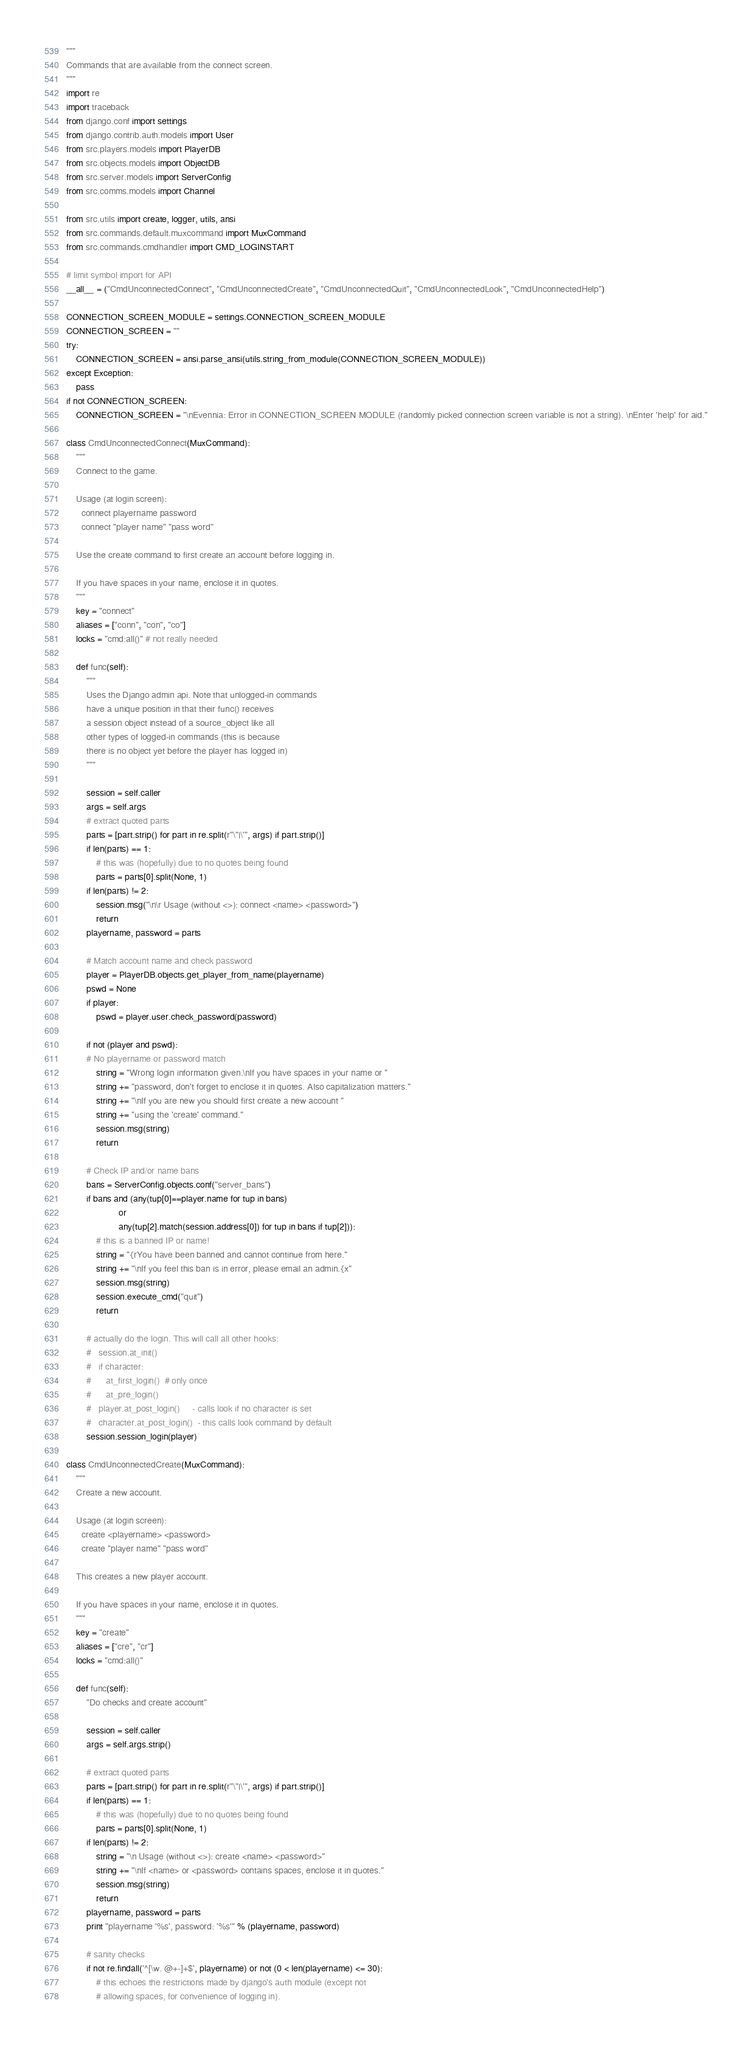Convert code to text. <code><loc_0><loc_0><loc_500><loc_500><_Python_>"""
Commands that are available from the connect screen.
"""
import re
import traceback
from django.conf import settings
from django.contrib.auth.models import User
from src.players.models import PlayerDB
from src.objects.models import ObjectDB
from src.server.models import ServerConfig
from src.comms.models import Channel

from src.utils import create, logger, utils, ansi
from src.commands.default.muxcommand import MuxCommand
from src.commands.cmdhandler import CMD_LOGINSTART

# limit symbol import for API
__all__ = ("CmdUnconnectedConnect", "CmdUnconnectedCreate", "CmdUnconnectedQuit", "CmdUnconnectedLook", "CmdUnconnectedHelp")

CONNECTION_SCREEN_MODULE = settings.CONNECTION_SCREEN_MODULE
CONNECTION_SCREEN = ""
try:
    CONNECTION_SCREEN = ansi.parse_ansi(utils.string_from_module(CONNECTION_SCREEN_MODULE))
except Exception:
    pass
if not CONNECTION_SCREEN:
    CONNECTION_SCREEN = "\nEvennia: Error in CONNECTION_SCREEN MODULE (randomly picked connection screen variable is not a string). \nEnter 'help' for aid."

class CmdUnconnectedConnect(MuxCommand):
    """
    Connect to the game.

    Usage (at login screen):
      connect playername password
      connect "player name" "pass word"

    Use the create command to first create an account before logging in.

    If you have spaces in your name, enclose it in quotes.
    """
    key = "connect"
    aliases = ["conn", "con", "co"]
    locks = "cmd:all()" # not really needed

    def func(self):
        """
        Uses the Django admin api. Note that unlogged-in commands
        have a unique position in that their func() receives
        a session object instead of a source_object like all
        other types of logged-in commands (this is because
        there is no object yet before the player has logged in)
        """

        session = self.caller
        args = self.args
        # extract quoted parts
        parts = [part.strip() for part in re.split(r"\"|\'", args) if part.strip()]
        if len(parts) == 1:
            # this was (hopefully) due to no quotes being found
            parts = parts[0].split(None, 1)
        if len(parts) != 2:
            session.msg("\n\r Usage (without <>): connect <name> <password>")
            return
        playername, password = parts

        # Match account name and check password
        player = PlayerDB.objects.get_player_from_name(playername)
        pswd = None
        if player:
            pswd = player.user.check_password(password)

        if not (player and pswd):
        # No playername or password match
            string = "Wrong login information given.\nIf you have spaces in your name or "
            string += "password, don't forget to enclose it in quotes. Also capitalization matters."
            string += "\nIf you are new you should first create a new account "
            string += "using the 'create' command."
            session.msg(string)
            return

        # Check IP and/or name bans
        bans = ServerConfig.objects.conf("server_bans")
        if bans and (any(tup[0]==player.name for tup in bans)
                     or
                     any(tup[2].match(session.address[0]) for tup in bans if tup[2])):
            # this is a banned IP or name!
            string = "{rYou have been banned and cannot continue from here."
            string += "\nIf you feel this ban is in error, please email an admin.{x"
            session.msg(string)
            session.execute_cmd("quit")
            return

        # actually do the login. This will call all other hooks:
        #   session.at_init()
        #   if character:
        #      at_first_login()  # only once
        #      at_pre_login()
        #   player.at_post_login()     - calls look if no character is set
        #   character.at_post_login()  - this calls look command by default
        session.session_login(player)

class CmdUnconnectedCreate(MuxCommand):
    """
    Create a new account.

    Usage (at login screen):
      create <playername> <password>
      create "player name" "pass word"

    This creates a new player account.

    If you have spaces in your name, enclose it in quotes.
    """
    key = "create"
    aliases = ["cre", "cr"]
    locks = "cmd:all()"

    def func(self):
        "Do checks and create account"

        session = self.caller
        args = self.args.strip()

        # extract quoted parts
        parts = [part.strip() for part in re.split(r"\"|\'", args) if part.strip()]
        if len(parts) == 1:
            # this was (hopefully) due to no quotes being found
            parts = parts[0].split(None, 1)
        if len(parts) != 2:
            string = "\n Usage (without <>): create <name> <password>"
            string += "\nIf <name> or <password> contains spaces, enclose it in quotes."
            session.msg(string)
            return
        playername, password = parts
        print "playername '%s', password: '%s'" % (playername, password)

        # sanity checks
        if not re.findall('^[\w. @+-]+$', playername) or not (0 < len(playername) <= 30):
            # this echoes the restrictions made by django's auth module (except not
            # allowing spaces, for convenience of logging in).</code> 